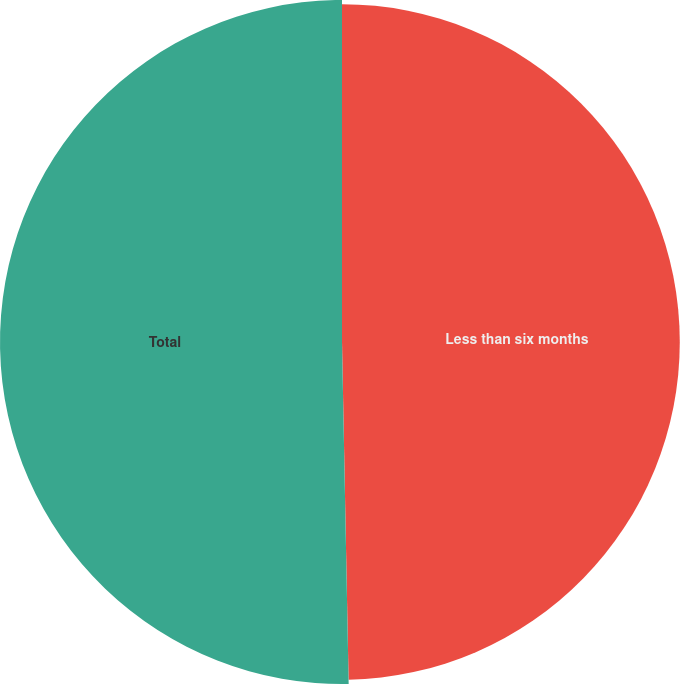Convert chart. <chart><loc_0><loc_0><loc_500><loc_500><pie_chart><fcel>Less than six months<fcel>Total<nl><fcel>49.69%<fcel>50.31%<nl></chart> 